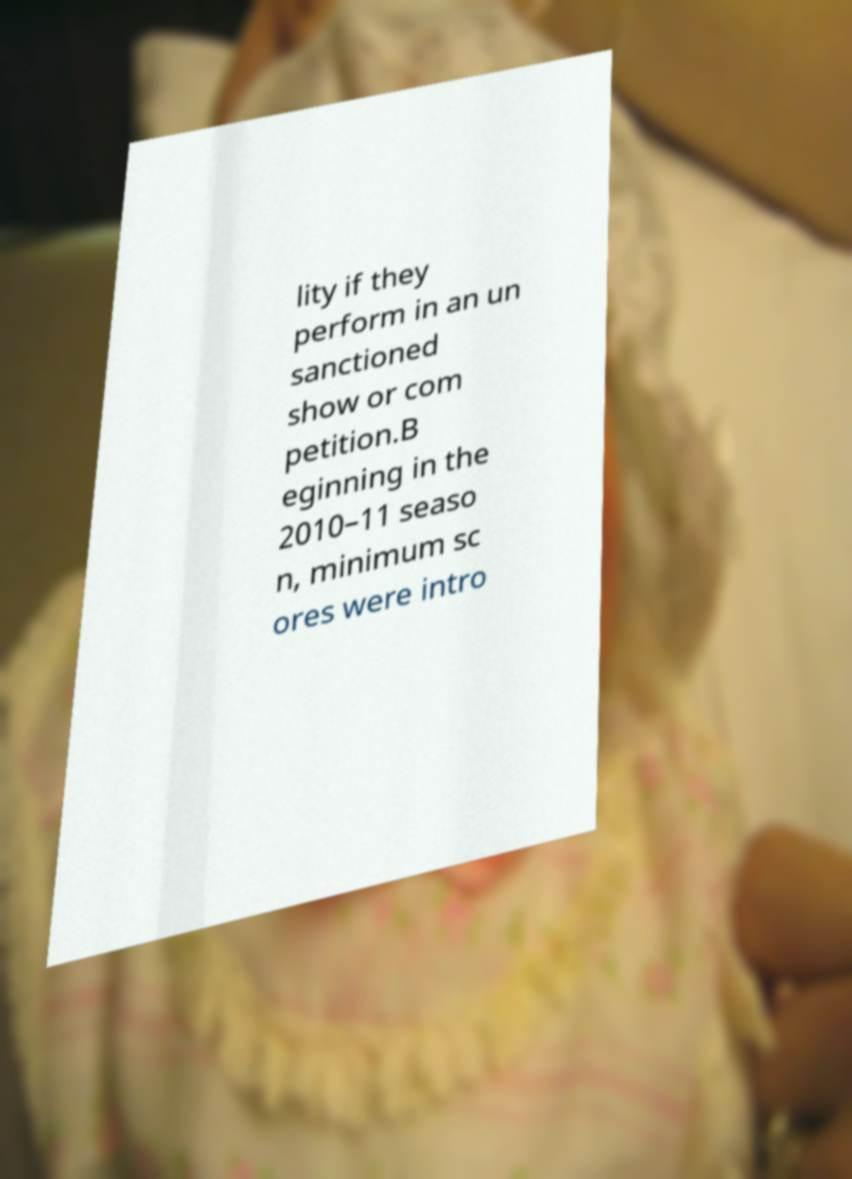What messages or text are displayed in this image? I need them in a readable, typed format. lity if they perform in an un sanctioned show or com petition.B eginning in the 2010–11 seaso n, minimum sc ores were intro 